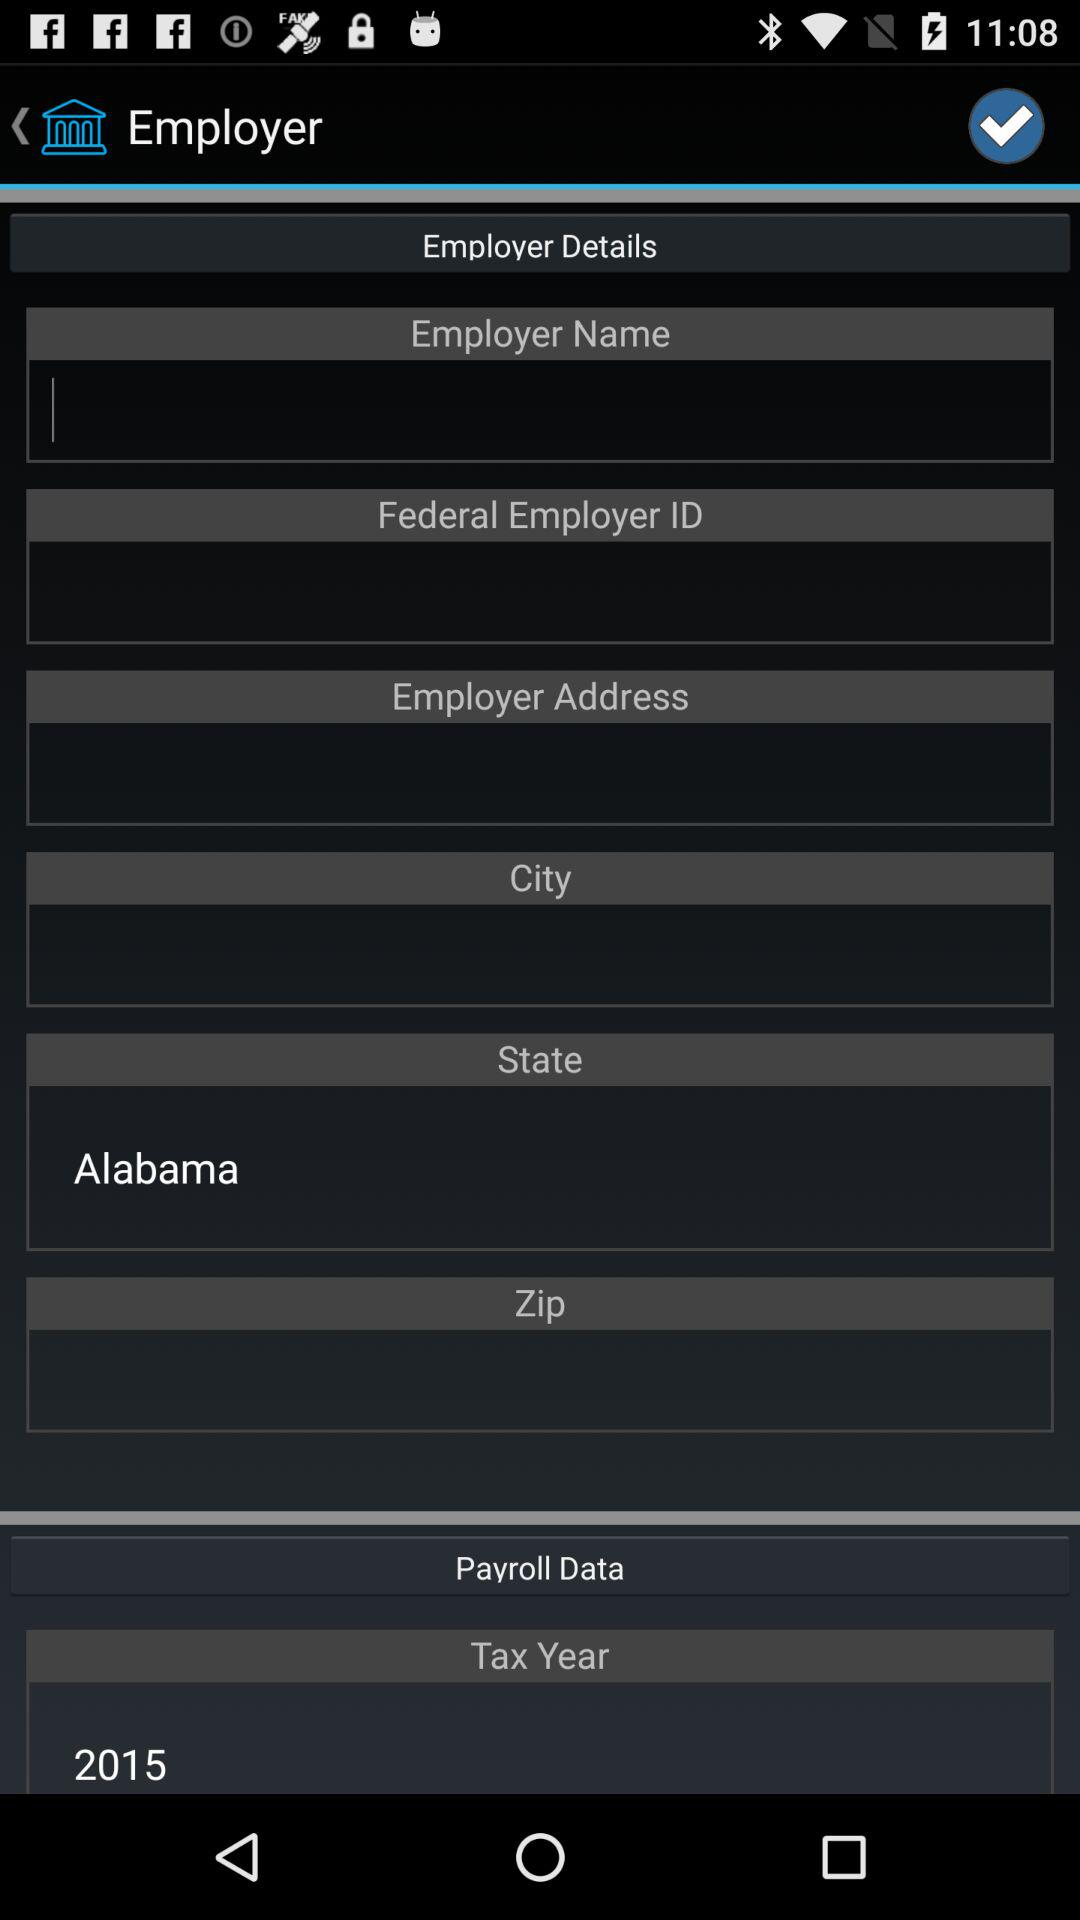What is the entered state? The entered state is Alabama. 